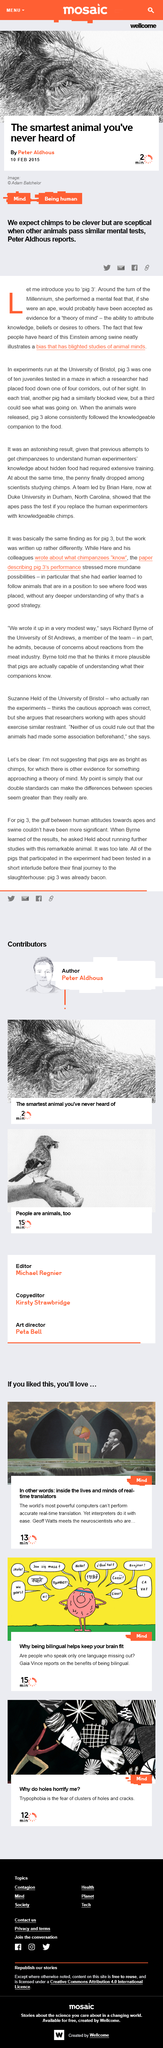Identify some key points in this picture. Pig 3 is described as being an Einstein among swine. The article on the smartest animal you've never heard of was written by Peter Aldhous, as featured in... The article on the smartest animal you've never heard of was published on 10 Feb 2015. 